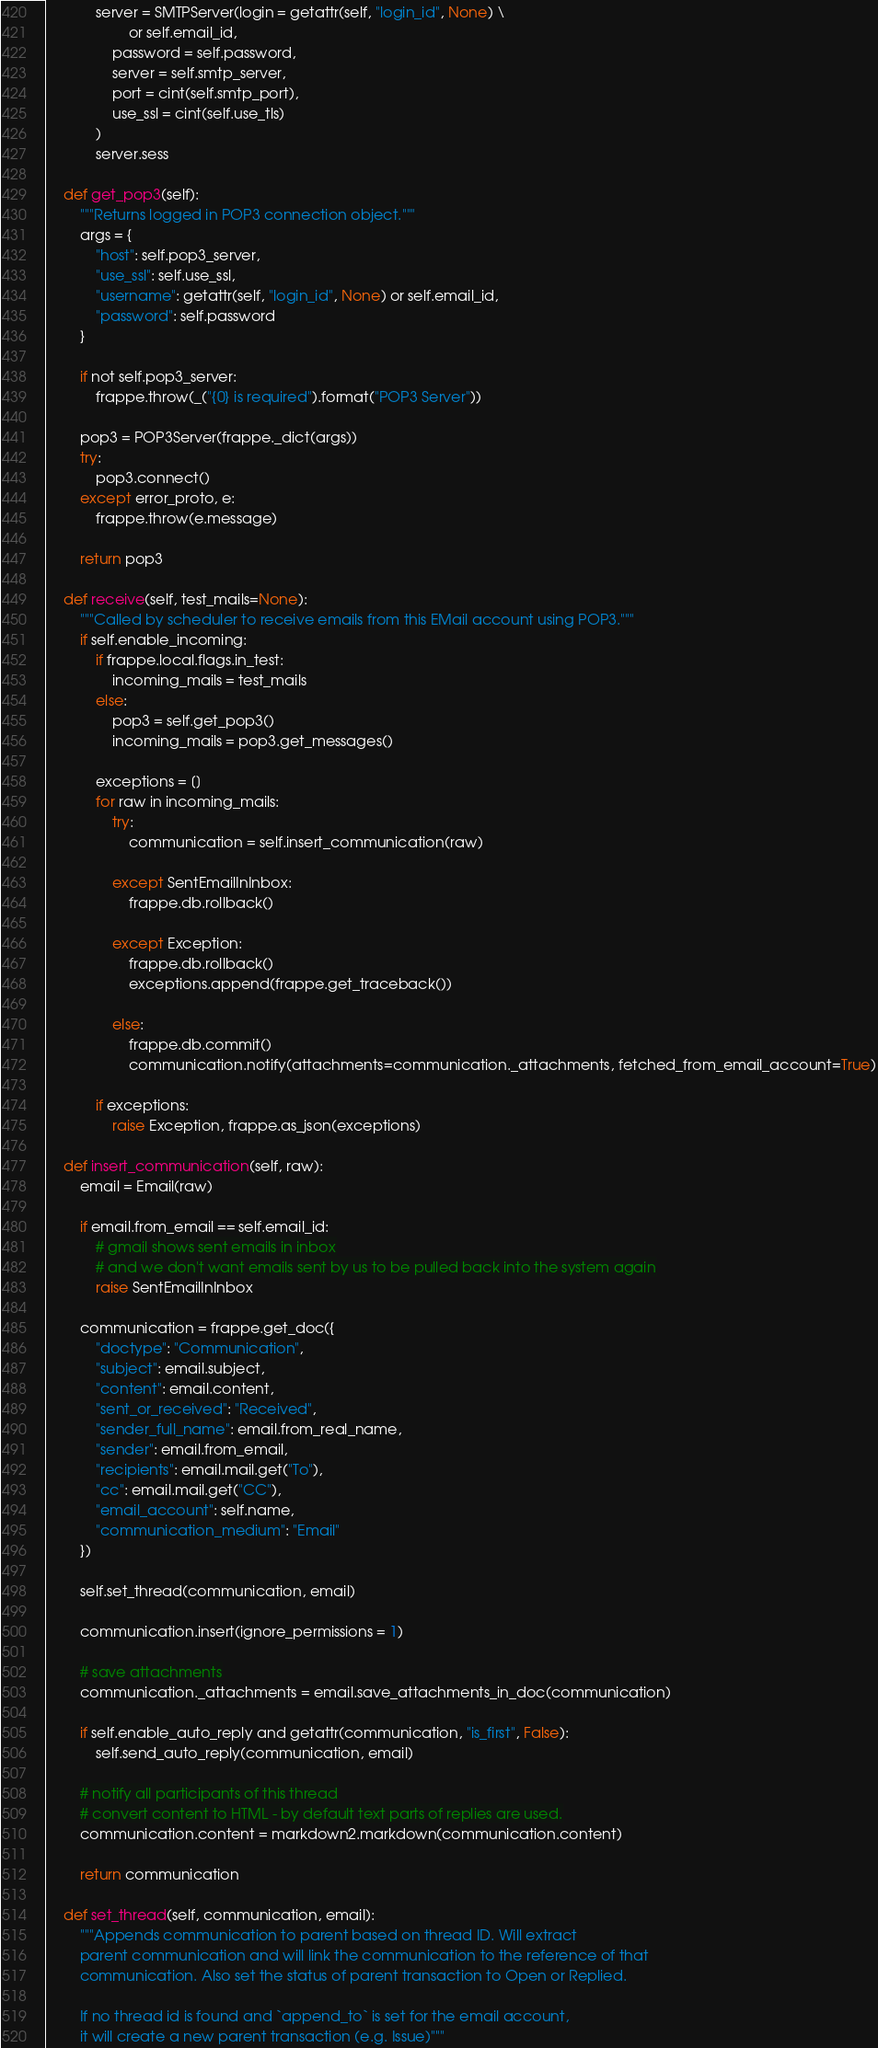<code> <loc_0><loc_0><loc_500><loc_500><_Python_>			server = SMTPServer(login = getattr(self, "login_id", None) \
					or self.email_id,
				password = self.password,
				server = self.smtp_server,
				port = cint(self.smtp_port),
				use_ssl = cint(self.use_tls)
			)
			server.sess

	def get_pop3(self):
		"""Returns logged in POP3 connection object."""
		args = {
			"host": self.pop3_server,
			"use_ssl": self.use_ssl,
			"username": getattr(self, "login_id", None) or self.email_id,
			"password": self.password
		}

		if not self.pop3_server:
			frappe.throw(_("{0} is required").format("POP3 Server"))

		pop3 = POP3Server(frappe._dict(args))
		try:
			pop3.connect()
		except error_proto, e:
			frappe.throw(e.message)

		return pop3

	def receive(self, test_mails=None):
		"""Called by scheduler to receive emails from this EMail account using POP3."""
		if self.enable_incoming:
			if frappe.local.flags.in_test:
				incoming_mails = test_mails
			else:
				pop3 = self.get_pop3()
				incoming_mails = pop3.get_messages()

			exceptions = []
			for raw in incoming_mails:
				try:
					communication = self.insert_communication(raw)

				except SentEmailInInbox:
					frappe.db.rollback()

				except Exception:
					frappe.db.rollback()
					exceptions.append(frappe.get_traceback())

				else:
					frappe.db.commit()
					communication.notify(attachments=communication._attachments, fetched_from_email_account=True)

			if exceptions:
				raise Exception, frappe.as_json(exceptions)

	def insert_communication(self, raw):
		email = Email(raw)

		if email.from_email == self.email_id:
			# gmail shows sent emails in inbox
			# and we don't want emails sent by us to be pulled back into the system again
			raise SentEmailInInbox

		communication = frappe.get_doc({
			"doctype": "Communication",
			"subject": email.subject,
			"content": email.content,
			"sent_or_received": "Received",
			"sender_full_name": email.from_real_name,
			"sender": email.from_email,
			"recipients": email.mail.get("To"),
			"cc": email.mail.get("CC"),
			"email_account": self.name,
			"communication_medium": "Email"
		})

		self.set_thread(communication, email)

		communication.insert(ignore_permissions = 1)

		# save attachments
		communication._attachments = email.save_attachments_in_doc(communication)

		if self.enable_auto_reply and getattr(communication, "is_first", False):
			self.send_auto_reply(communication, email)

		# notify all participants of this thread
		# convert content to HTML - by default text parts of replies are used.
		communication.content = markdown2.markdown(communication.content)

		return communication

	def set_thread(self, communication, email):
		"""Appends communication to parent based on thread ID. Will extract
		parent communication and will link the communication to the reference of that
		communication. Also set the status of parent transaction to Open or Replied.

		If no thread id is found and `append_to` is set for the email account,
		it will create a new parent transaction (e.g. Issue)"""</code> 